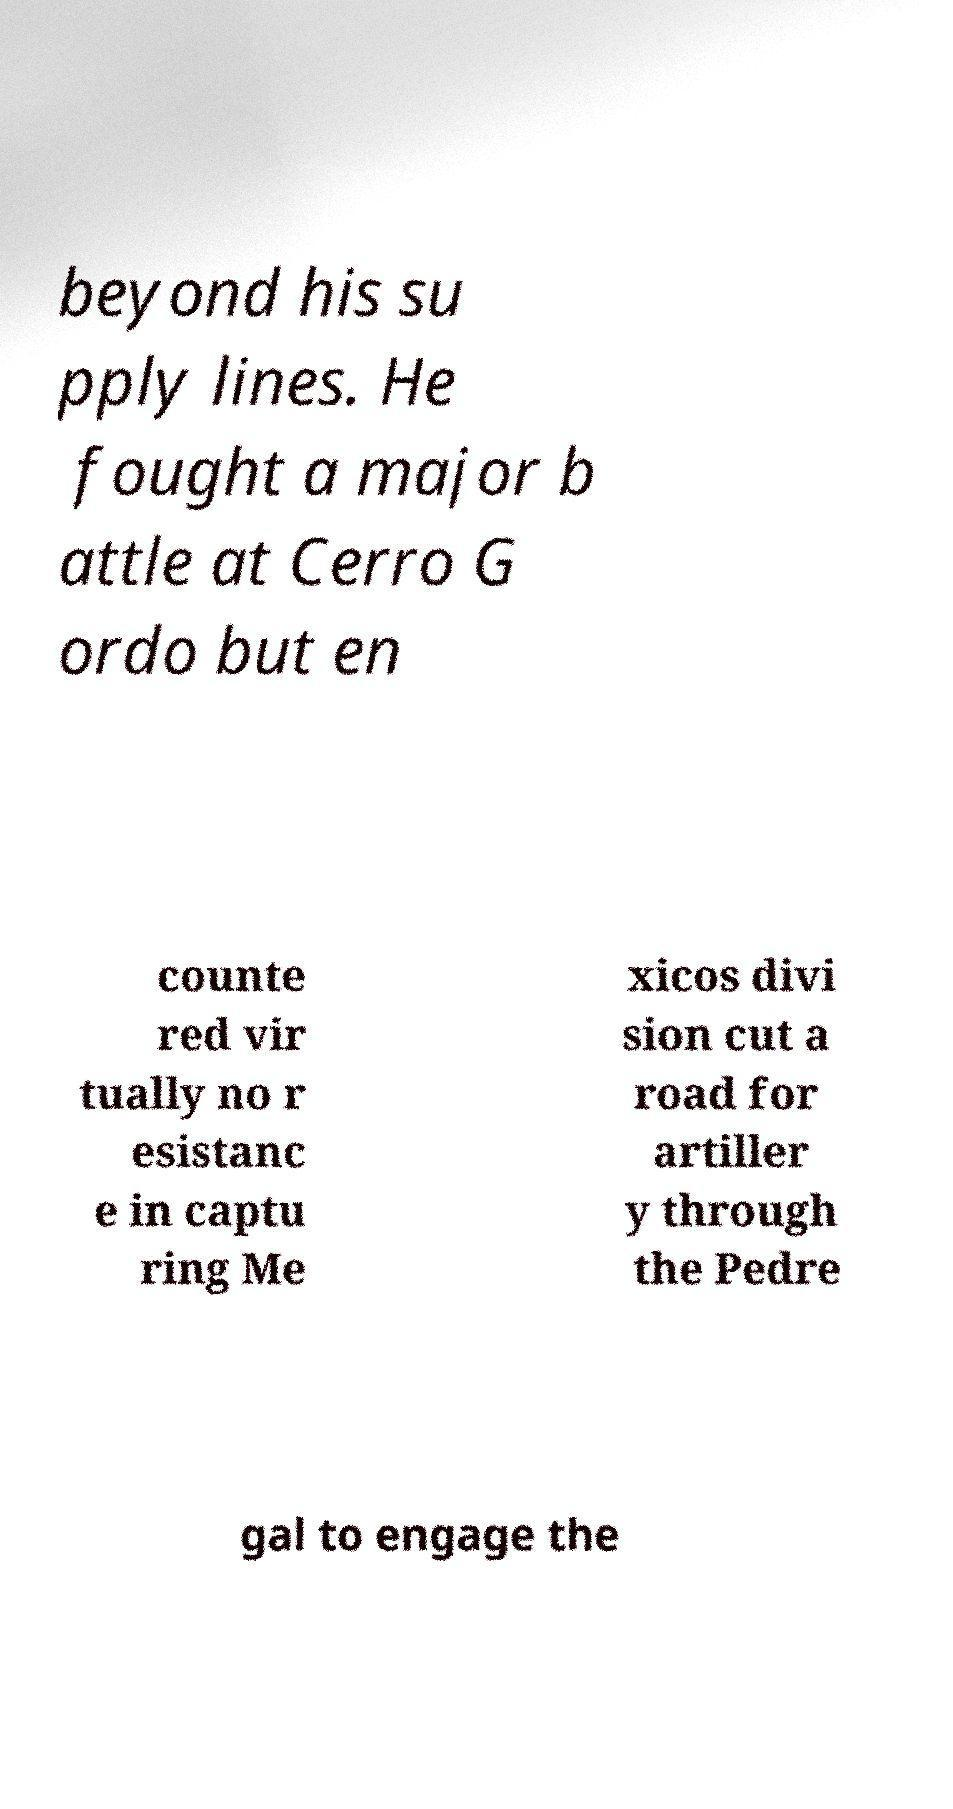I need the written content from this picture converted into text. Can you do that? beyond his su pply lines. He fought a major b attle at Cerro G ordo but en counte red vir tually no r esistanc e in captu ring Me xicos divi sion cut a road for artiller y through the Pedre gal to engage the 